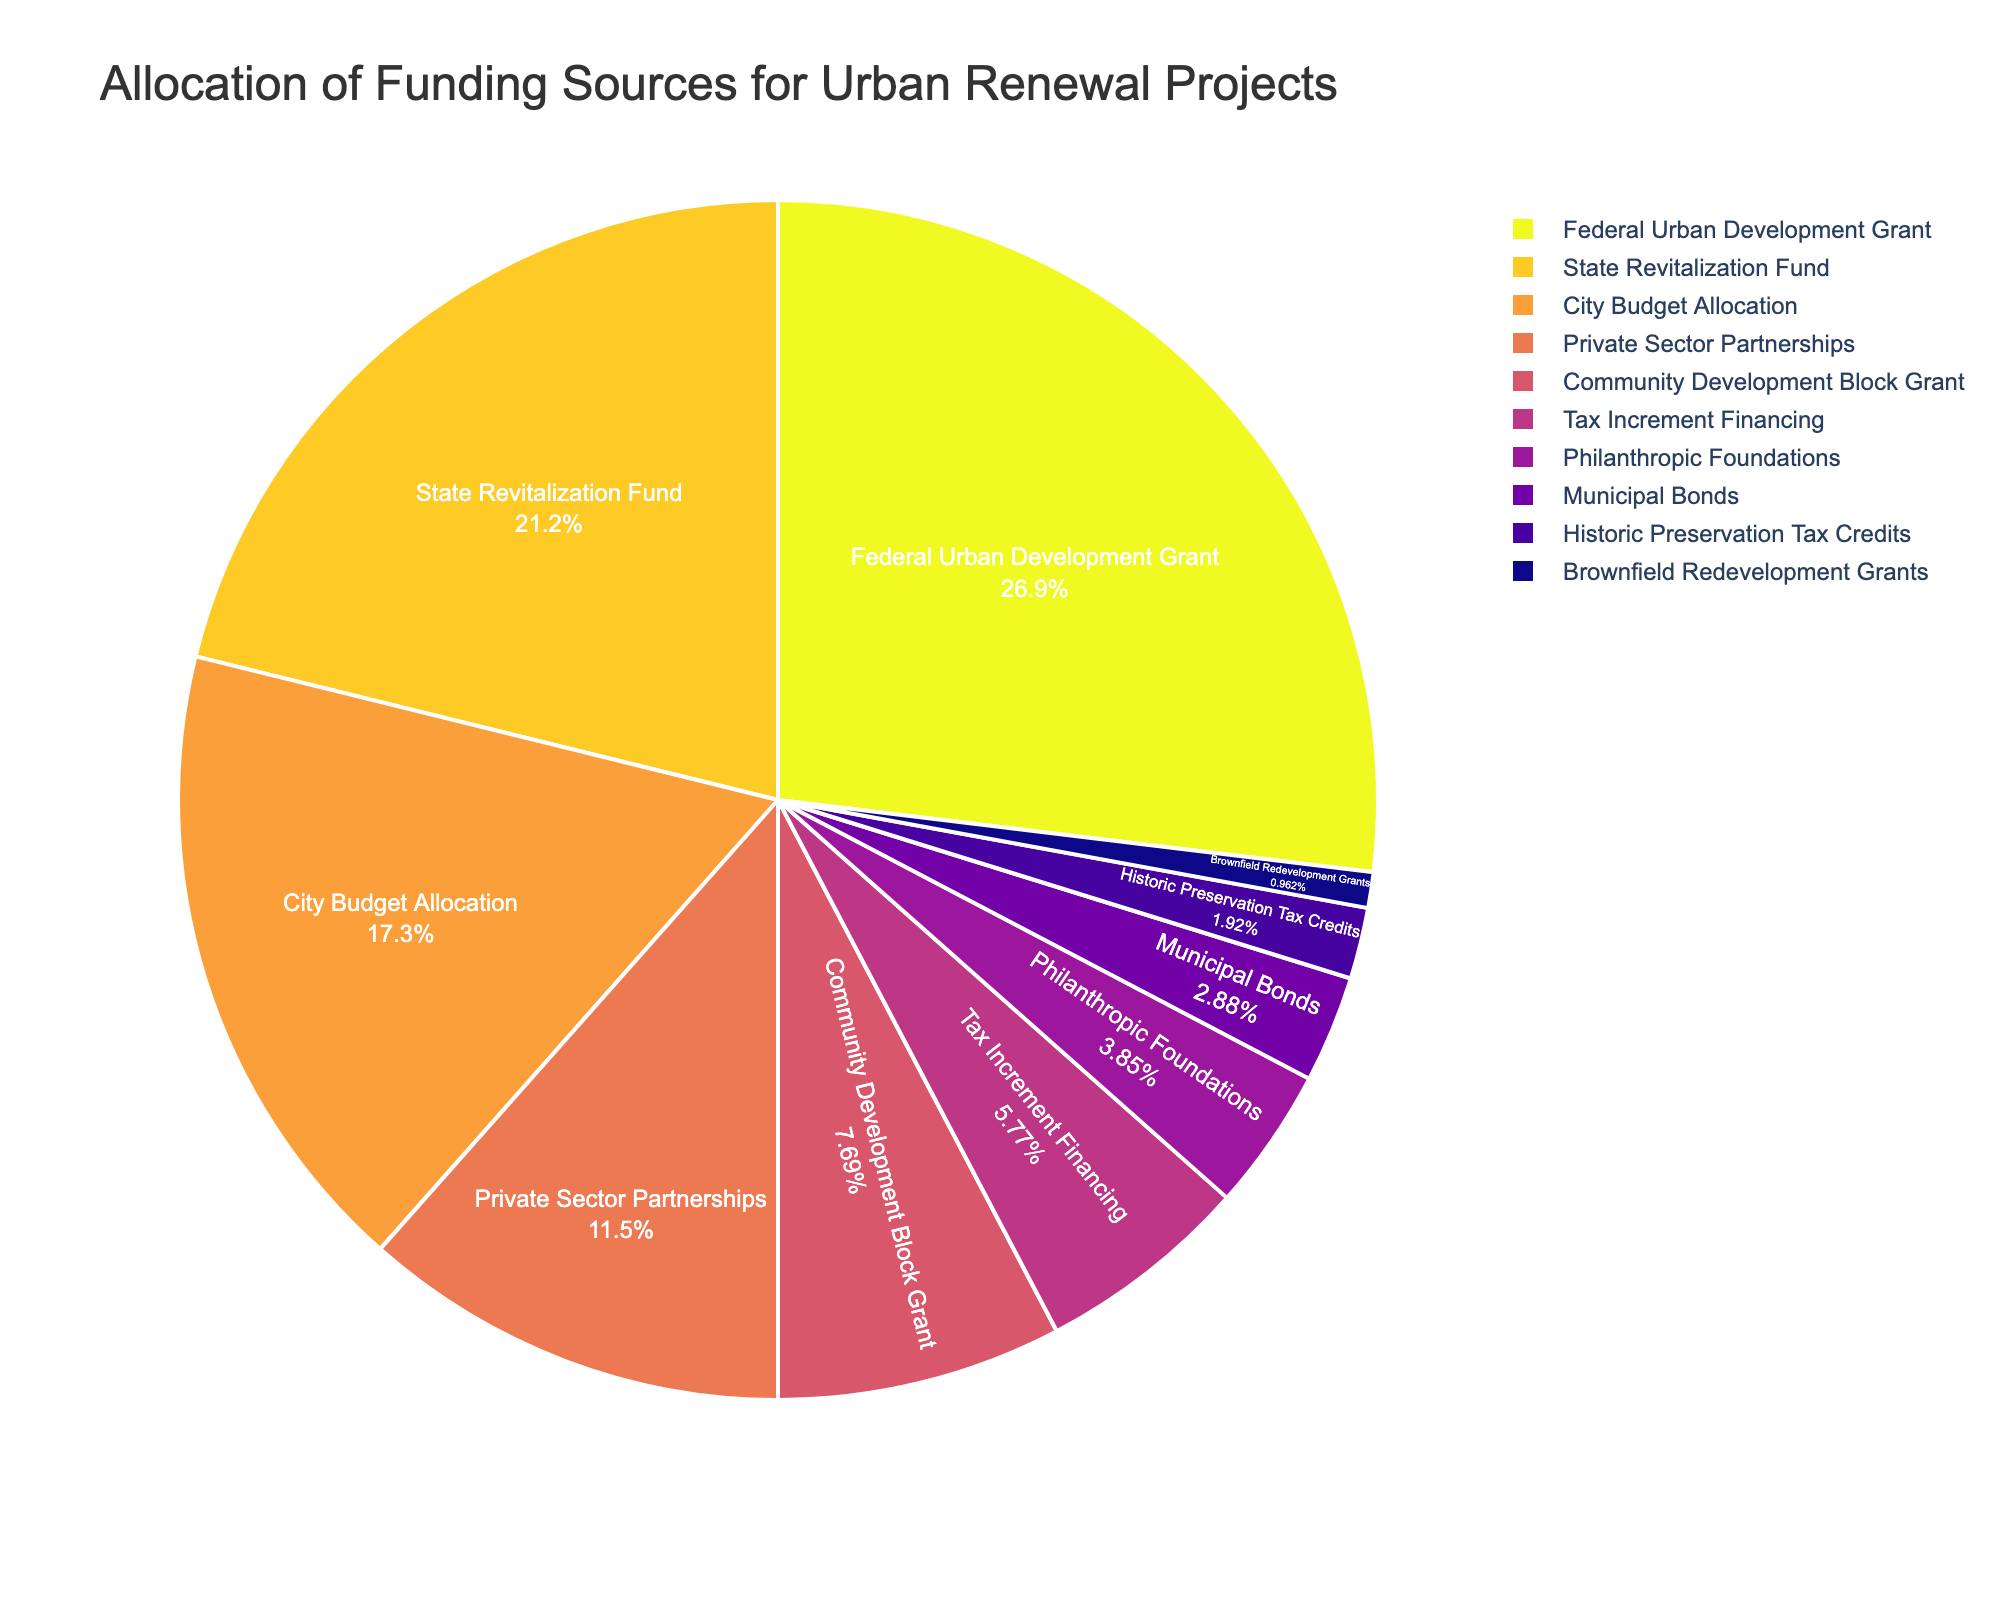How much more percentage does the Federal Urban Development Grant contribute compared to the City Budget Allocation? The Federal Urban Development Grant contributes 28%, while the City Budget Allocation contributes 18%. The difference is calculated as 28% - 18% = 10%.
Answer: 10% What is the total percentage contribution from the Community Development Block Grant, Tax Increment Financing, and Philanthropic Foundations? The Community Development Block Grant contributes 8%, Tax Increment Financing 6%, and Philanthropic Foundations 4%. Summing these percentages: 8% + 6% + 4% = 18%.
Answer: 18% Which funding source has the smallest contribution to the allocation and what is its percentage? Brownfield Redevelopment Grants have the smallest contribution at 1%.
Answer: Brownfield Redevelopment Grants, 1% Is the percentage contribution of Private Sector Partnerships greater than or equal to the sum of Municipal Bonds and Historic Preservation Tax Credits? Private Sector Partnerships contribute 12%. Municipal Bonds contribute 3%, and Historic Preservation Tax Credits contribute 2%, which sum up to 3% + 2% = 5%. Since 12% > 5%, the Private Sector Partnerships contribution is greater.
Answer: Yes How many funding sources contribute less than 10%? The funding sources contributing less than 10% are Community Development Block Grant (8%), Tax Increment Financing (6%), Philanthropic Foundations (4%), Municipal Bonds (3%), Historic Preservation Tax Credits (2%), and Brownfield Redevelopment Grants (1%). There are 6 such sources.
Answer: 6 Is the combined percentage of State Revitalization Fund and City Budget Allocation more or less than the combined percentage of Federal Urban Development Grant and Private Sector Partnerships? State Revitalization Fund and City Budget Allocation together contribute 22% + 18% = 40%. Federal Urban Development Grant and Private Sector Partnerships together contribute 28% + 12% = 40%. So, both combinations contribute equally.
Answer: Equal What is the percentage difference between Tax Increment Financing and Municipal Bonds? Tax Increment Financing contributes 6% while Municipal Bonds contribute 3%. The difference is 6% - 3% = 3%.
Answer: 3% Which portion (color) represents the Federal Urban Development Grant? In the pie chart, the Federal Urban Development Grant represents the section of the pie chart with a specific color that is used for this category. This color would be distinct and visually identifiable. Given the custom palette, the exact color might not be specified naturally here but is one of the prominent parts of the pie.
Answer: Distinct section in the pie chart Is more funding allocated from the State Revitalization Fund or from the City Budget Allocation? By how much? The State Revitalization Fund contributes 22%, whereas the City Budget Allocation contributes 18%. The difference is calculated as 22% - 18% = 4%.
Answer: State Revitalization Fund by 4% Do the combined contributions of Federal Urban Development Grant, State Revitalization Fund, and City Budget Allocation make up more than half of the total funding? The Federal Urban Development Grant contributes 28%, the State Revitalization Fund 22%, and the City Budget Allocation 18%. Adding these together: 28% + 22% + 18% = 68%. Since 68% > 50%, they make up more than half of the total funding.
Answer: Yes 